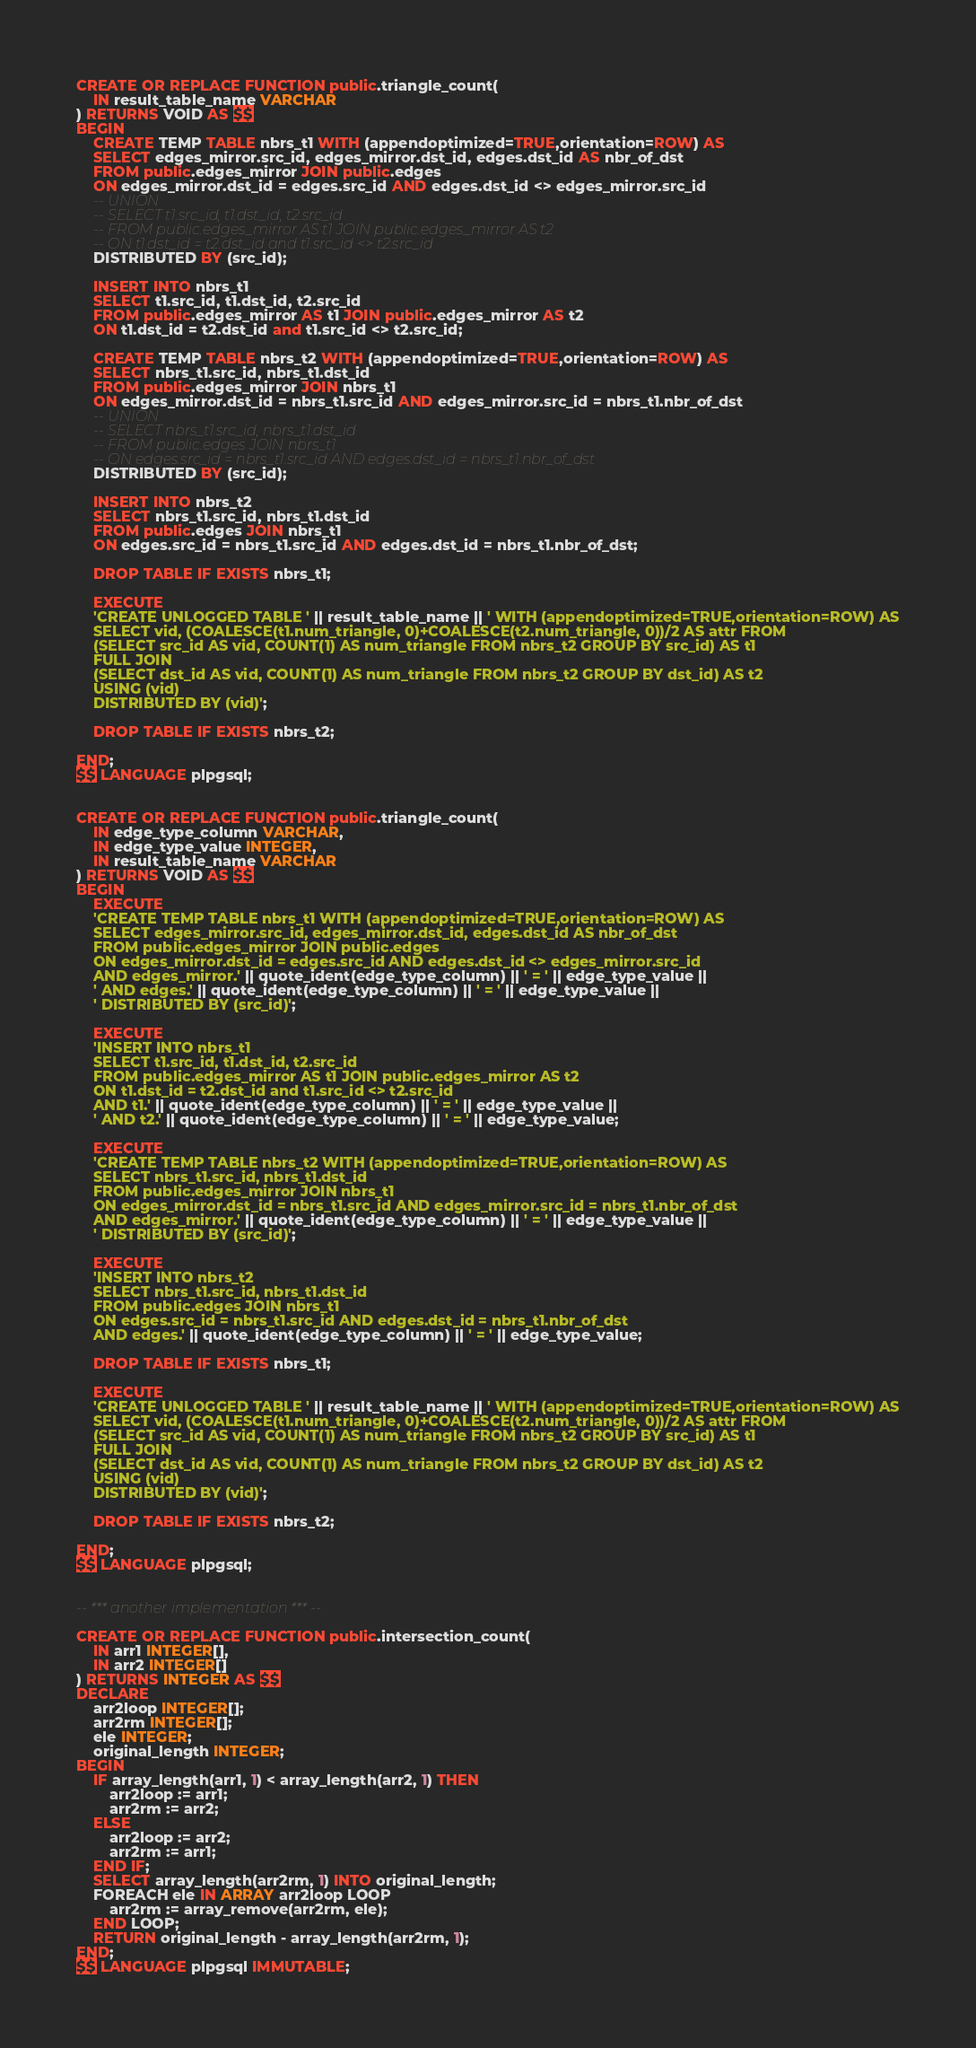Convert code to text. <code><loc_0><loc_0><loc_500><loc_500><_SQL_>CREATE OR REPLACE FUNCTION public.triangle_count(
    IN result_table_name VARCHAR
) RETURNS VOID AS $$
BEGIN
    CREATE TEMP TABLE nbrs_t1 WITH (appendoptimized=TRUE,orientation=ROW) AS
    SELECT edges_mirror.src_id, edges_mirror.dst_id, edges.dst_id AS nbr_of_dst
    FROM public.edges_mirror JOIN public.edges 
    ON edges_mirror.dst_id = edges.src_id AND edges.dst_id <> edges_mirror.src_id
    -- UNION
    -- SELECT t1.src_id, t1.dst_id, t2.src_id
    -- FROM public.edges_mirror AS t1 JOIN public.edges_mirror AS t2
    -- ON t1.dst_id = t2.dst_id and t1.src_id <> t2.src_id
    DISTRIBUTED BY (src_id);

    INSERT INTO nbrs_t1
    SELECT t1.src_id, t1.dst_id, t2.src_id
    FROM public.edges_mirror AS t1 JOIN public.edges_mirror AS t2
    ON t1.dst_id = t2.dst_id and t1.src_id <> t2.src_id;

    CREATE TEMP TABLE nbrs_t2 WITH (appendoptimized=TRUE,orientation=ROW) AS
    SELECT nbrs_t1.src_id, nbrs_t1.dst_id
    FROM public.edges_mirror JOIN nbrs_t1
    ON edges_mirror.dst_id = nbrs_t1.src_id AND edges_mirror.src_id = nbrs_t1.nbr_of_dst
    -- UNION 
    -- SELECT nbrs_t1.src_id, nbrs_t1.dst_id
    -- FROM public.edges JOIN nbrs_t1
    -- ON edges.src_id = nbrs_t1.src_id AND edges.dst_id = nbrs_t1.nbr_of_dst
    DISTRIBUTED BY (src_id);

    INSERT INTO nbrs_t2
    SELECT nbrs_t1.src_id, nbrs_t1.dst_id
    FROM public.edges JOIN nbrs_t1
    ON edges.src_id = nbrs_t1.src_id AND edges.dst_id = nbrs_t1.nbr_of_dst;

    DROP TABLE IF EXISTS nbrs_t1;

    EXECUTE
    'CREATE UNLOGGED TABLE ' || result_table_name || ' WITH (appendoptimized=TRUE,orientation=ROW) AS
    SELECT vid, (COALESCE(t1.num_triangle, 0)+COALESCE(t2.num_triangle, 0))/2 AS attr FROM
    (SELECT src_id AS vid, COUNT(1) AS num_triangle FROM nbrs_t2 GROUP BY src_id) AS t1
    FULL JOIN
    (SELECT dst_id AS vid, COUNT(1) AS num_triangle FROM nbrs_t2 GROUP BY dst_id) AS t2
    USING (vid)
    DISTRIBUTED BY (vid)';

    DROP TABLE IF EXISTS nbrs_t2;

END;
$$ LANGUAGE plpgsql;


CREATE OR REPLACE FUNCTION public.triangle_count(
    IN edge_type_column VARCHAR, 
    IN edge_type_value INTEGER,
    IN result_table_name VARCHAR
) RETURNS VOID AS $$
BEGIN
    EXECUTE
    'CREATE TEMP TABLE nbrs_t1 WITH (appendoptimized=TRUE,orientation=ROW) AS
    SELECT edges_mirror.src_id, edges_mirror.dst_id, edges.dst_id AS nbr_of_dst
    FROM public.edges_mirror JOIN public.edges 
    ON edges_mirror.dst_id = edges.src_id AND edges.dst_id <> edges_mirror.src_id
    AND edges_mirror.' || quote_ident(edge_type_column) || ' = ' || edge_type_value ||
    ' AND edges.' || quote_ident(edge_type_column) || ' = ' || edge_type_value ||
    ' DISTRIBUTED BY (src_id)';

    EXECUTE
    'INSERT INTO nbrs_t1
    SELECT t1.src_id, t1.dst_id, t2.src_id
    FROM public.edges_mirror AS t1 JOIN public.edges_mirror AS t2
    ON t1.dst_id = t2.dst_id and t1.src_id <> t2.src_id
    AND t1.' || quote_ident(edge_type_column) || ' = ' || edge_type_value ||
    ' AND t2.' || quote_ident(edge_type_column) || ' = ' || edge_type_value;

    EXECUTE
    'CREATE TEMP TABLE nbrs_t2 WITH (appendoptimized=TRUE,orientation=ROW) AS
    SELECT nbrs_t1.src_id, nbrs_t1.dst_id
    FROM public.edges_mirror JOIN nbrs_t1
    ON edges_mirror.dst_id = nbrs_t1.src_id AND edges_mirror.src_id = nbrs_t1.nbr_of_dst
    AND edges_mirror.' || quote_ident(edge_type_column) || ' = ' || edge_type_value ||
    ' DISTRIBUTED BY (src_id)';

    EXECUTE
    'INSERT INTO nbrs_t2
    SELECT nbrs_t1.src_id, nbrs_t1.dst_id
    FROM public.edges JOIN nbrs_t1
    ON edges.src_id = nbrs_t1.src_id AND edges.dst_id = nbrs_t1.nbr_of_dst
    AND edges.' || quote_ident(edge_type_column) || ' = ' || edge_type_value;

    DROP TABLE IF EXISTS nbrs_t1;

    EXECUTE
    'CREATE UNLOGGED TABLE ' || result_table_name || ' WITH (appendoptimized=TRUE,orientation=ROW) AS
    SELECT vid, (COALESCE(t1.num_triangle, 0)+COALESCE(t2.num_triangle, 0))/2 AS attr FROM
    (SELECT src_id AS vid, COUNT(1) AS num_triangle FROM nbrs_t2 GROUP BY src_id) AS t1
    FULL JOIN
    (SELECT dst_id AS vid, COUNT(1) AS num_triangle FROM nbrs_t2 GROUP BY dst_id) AS t2
    USING (vid)
    DISTRIBUTED BY (vid)';

    DROP TABLE IF EXISTS nbrs_t2;

END;
$$ LANGUAGE plpgsql;


-- *** another implementation *** --

CREATE OR REPLACE FUNCTION public.intersection_count(
    IN arr1 INTEGER[],
    IN arr2 INTEGER[]
) RETURNS INTEGER AS $$
DECLARE
    arr2loop INTEGER[];
    arr2rm INTEGER[];
    ele INTEGER;
    original_length INTEGER;
BEGIN
    IF array_length(arr1, 1) < array_length(arr2, 1) THEN
        arr2loop := arr1;
        arr2rm := arr2;
    ELSE
        arr2loop := arr2;
        arr2rm := arr1;
    END IF;
    SELECT array_length(arr2rm, 1) INTO original_length;
    FOREACH ele IN ARRAY arr2loop LOOP
        arr2rm := array_remove(arr2rm, ele);
    END LOOP;
    RETURN original_length - array_length(arr2rm, 1);
END;
$$ LANGUAGE plpgsql IMMUTABLE;

</code> 